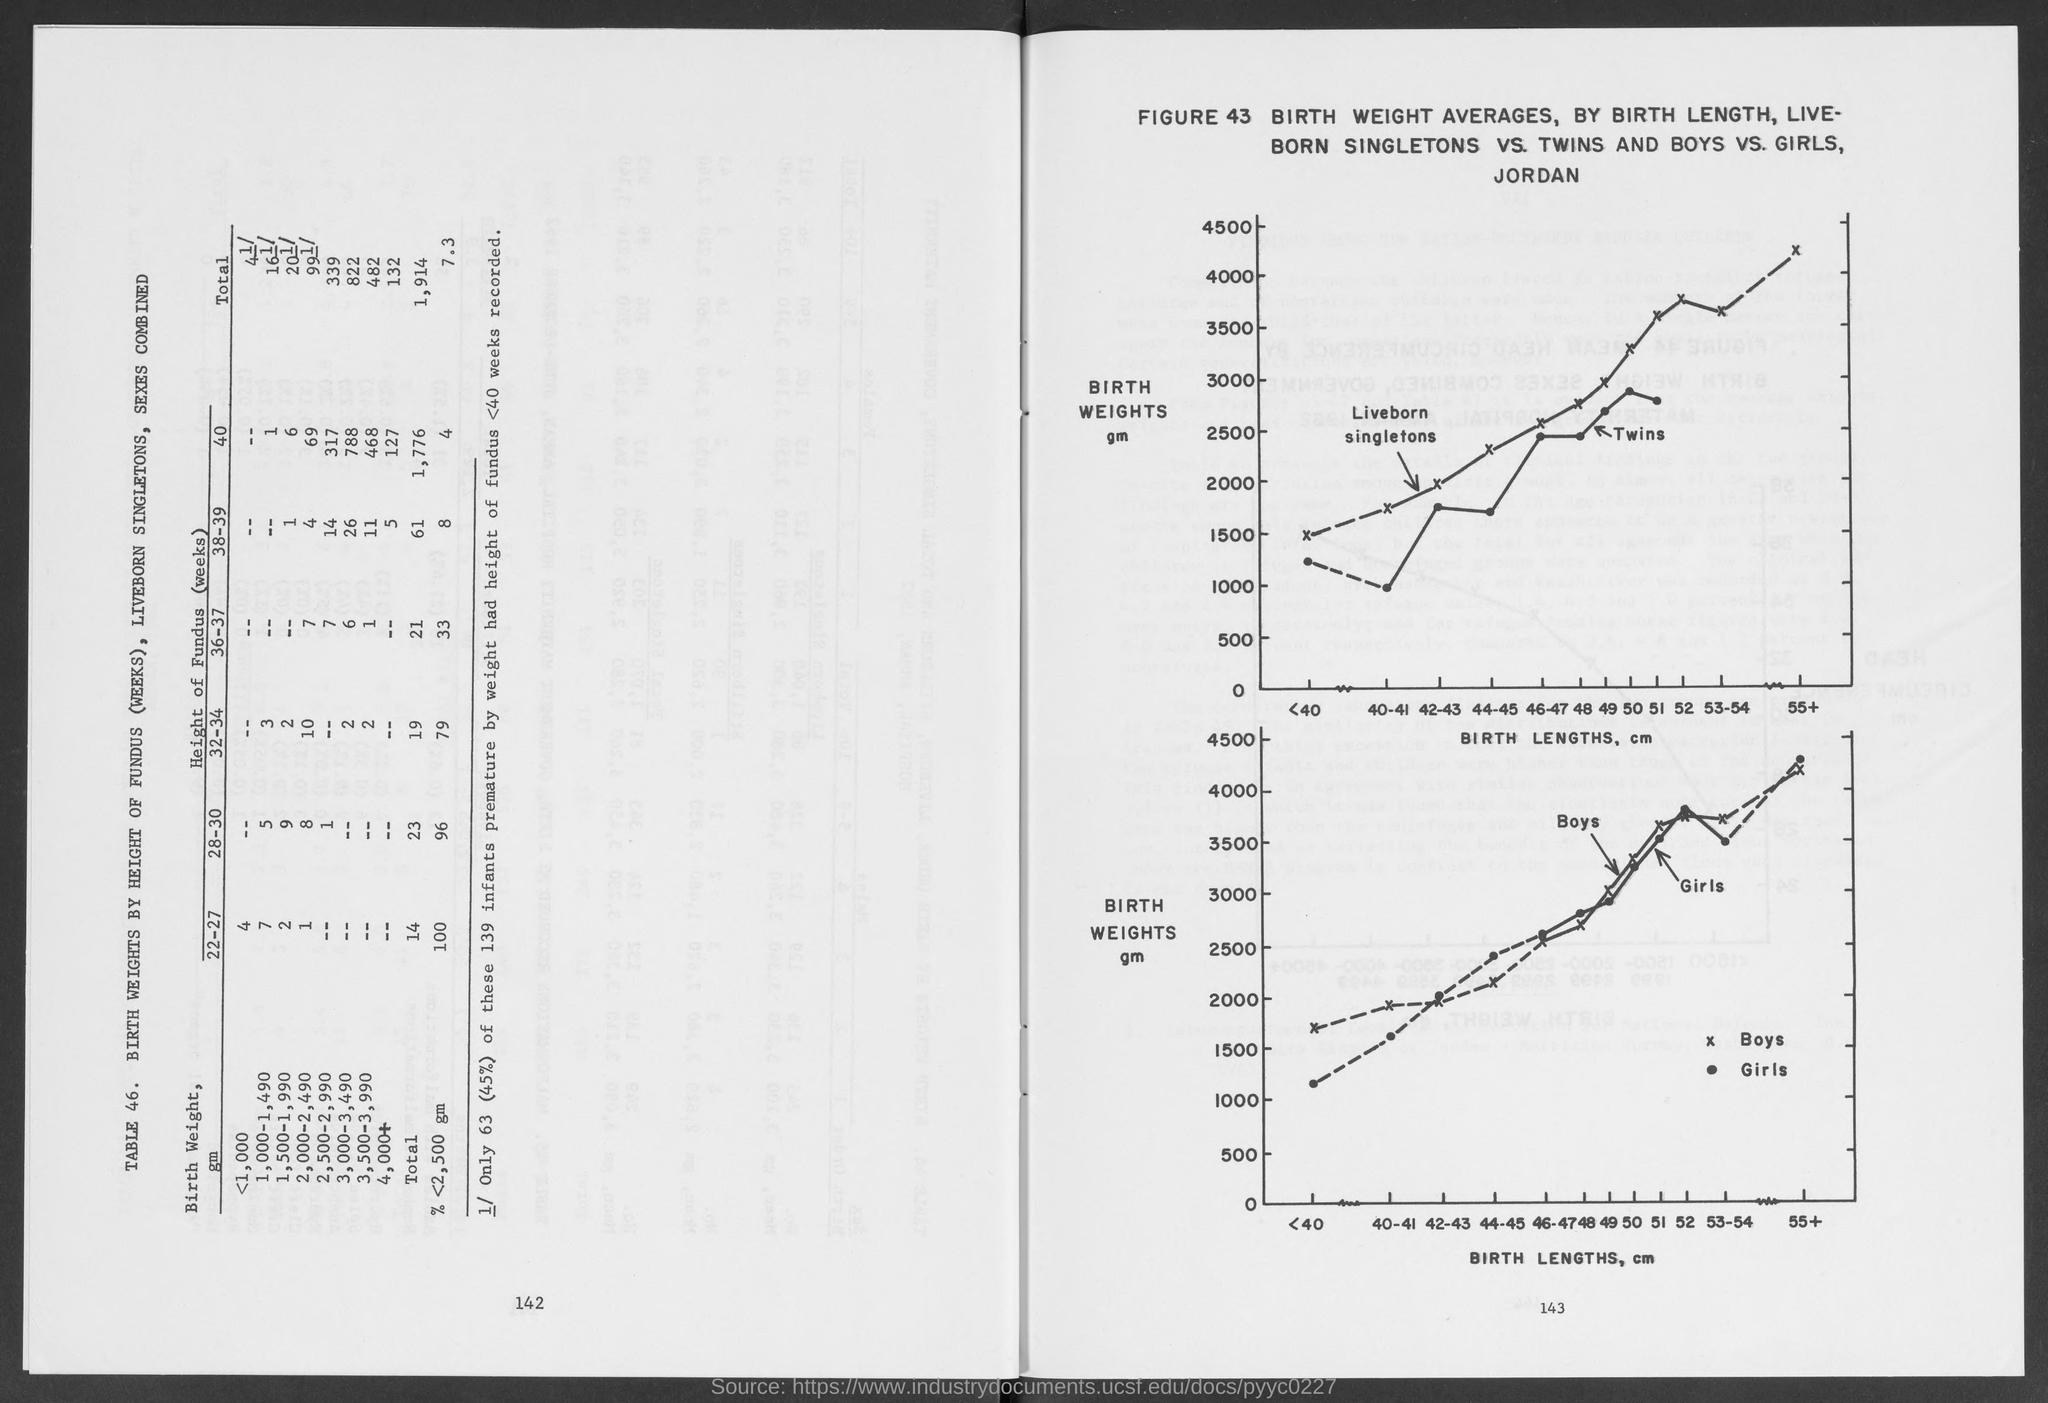List a handful of essential elements in this visual. Both graphs plot birth lengths, measured in centimeters, on the x-axis. The birth weights in both graphs are plotted on the y-axis and represent the grams of weight for each newborn. 